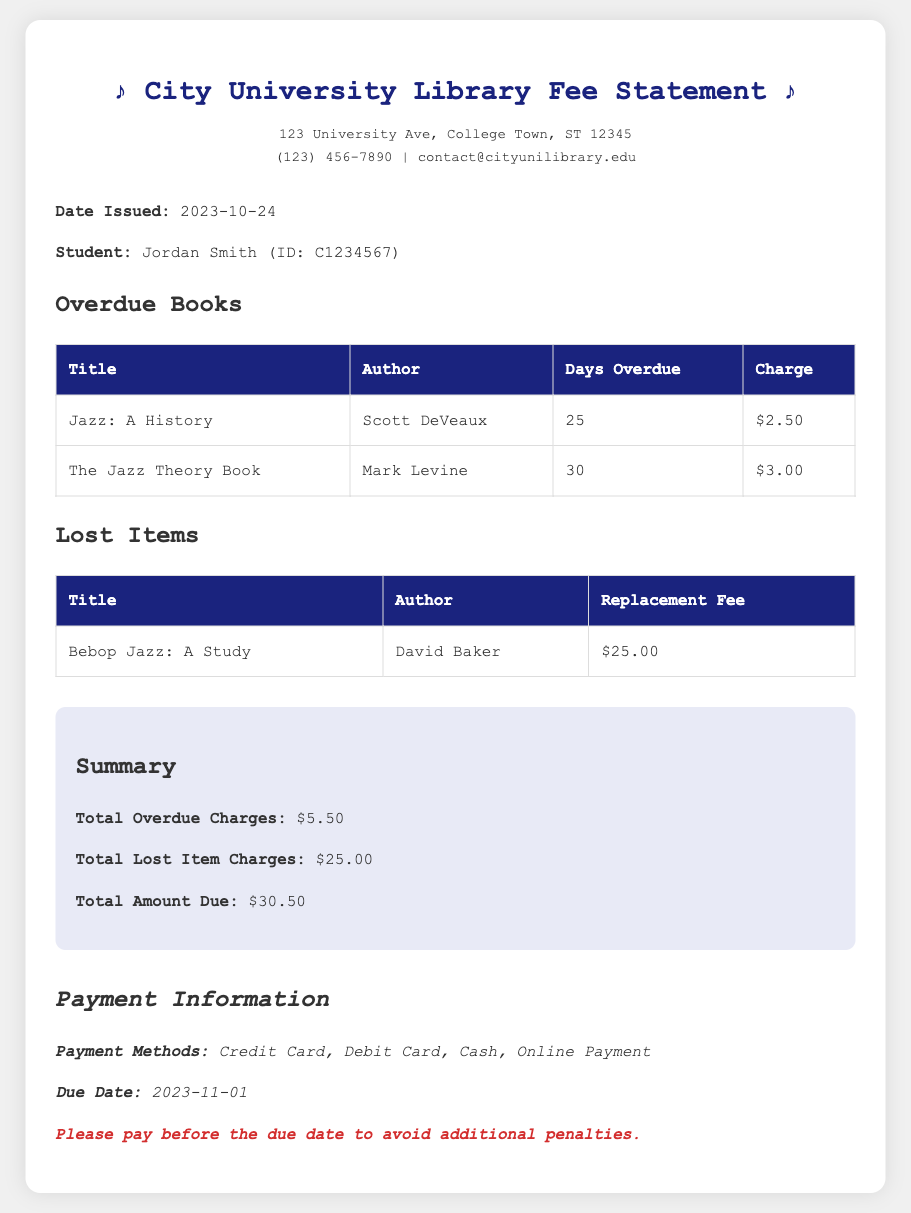What is the total amount due? The total amount due is the sum of overdue charges and lost item charges, which is $5.50 + $25.00.
Answer: $30.50 Who is the author of "The Jazz Theory Book"? The author's name is listed in the document next to the title "The Jazz Theory Book."
Answer: Mark Levine How many days overdue is "Jazz: A History"? The number of days overdue is specified in the table under "Days Overdue" for "Jazz: A History."
Answer: 25 What is the replacement fee for the lost item? The replacement fee is listed next to the title and author of the lost item in the document.
Answer: $25.00 When is the due date for payment? The due date is stated in the payment information section of the document.
Answer: 2023-11-01 What are the payment methods? The payment methods are mentioned in the payment information section.
Answer: Credit Card, Debit Card, Cash, Online Payment What is the total overdue charge? The total overdue charge is summed from the charges listed under "Overdue Books" in the document.
Answer: $5.50 What is the title of the lost item? The title of the lost item is identified in the "Lost Items" section of the document.
Answer: Bebop Jazz: A Study 